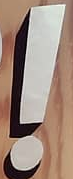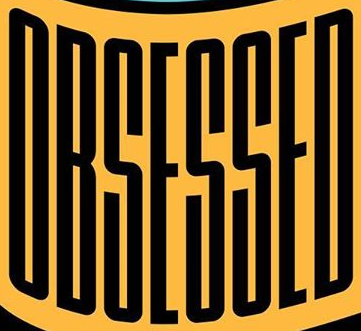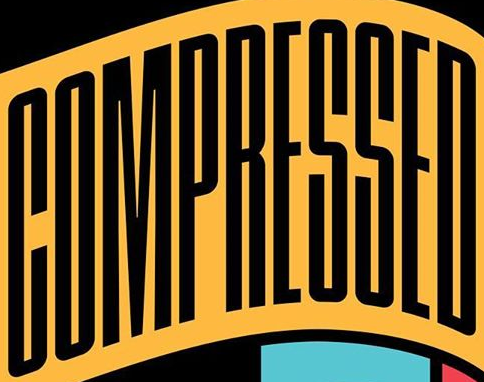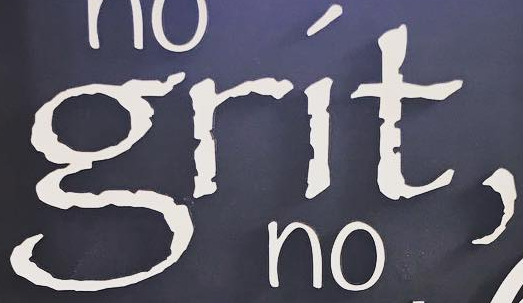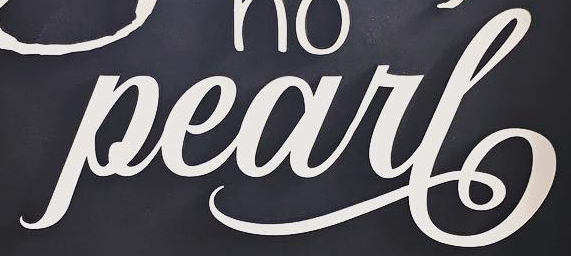What words are shown in these images in order, separated by a semicolon? !; OBSESSED; COMPRESSED; grít,; Pearl 